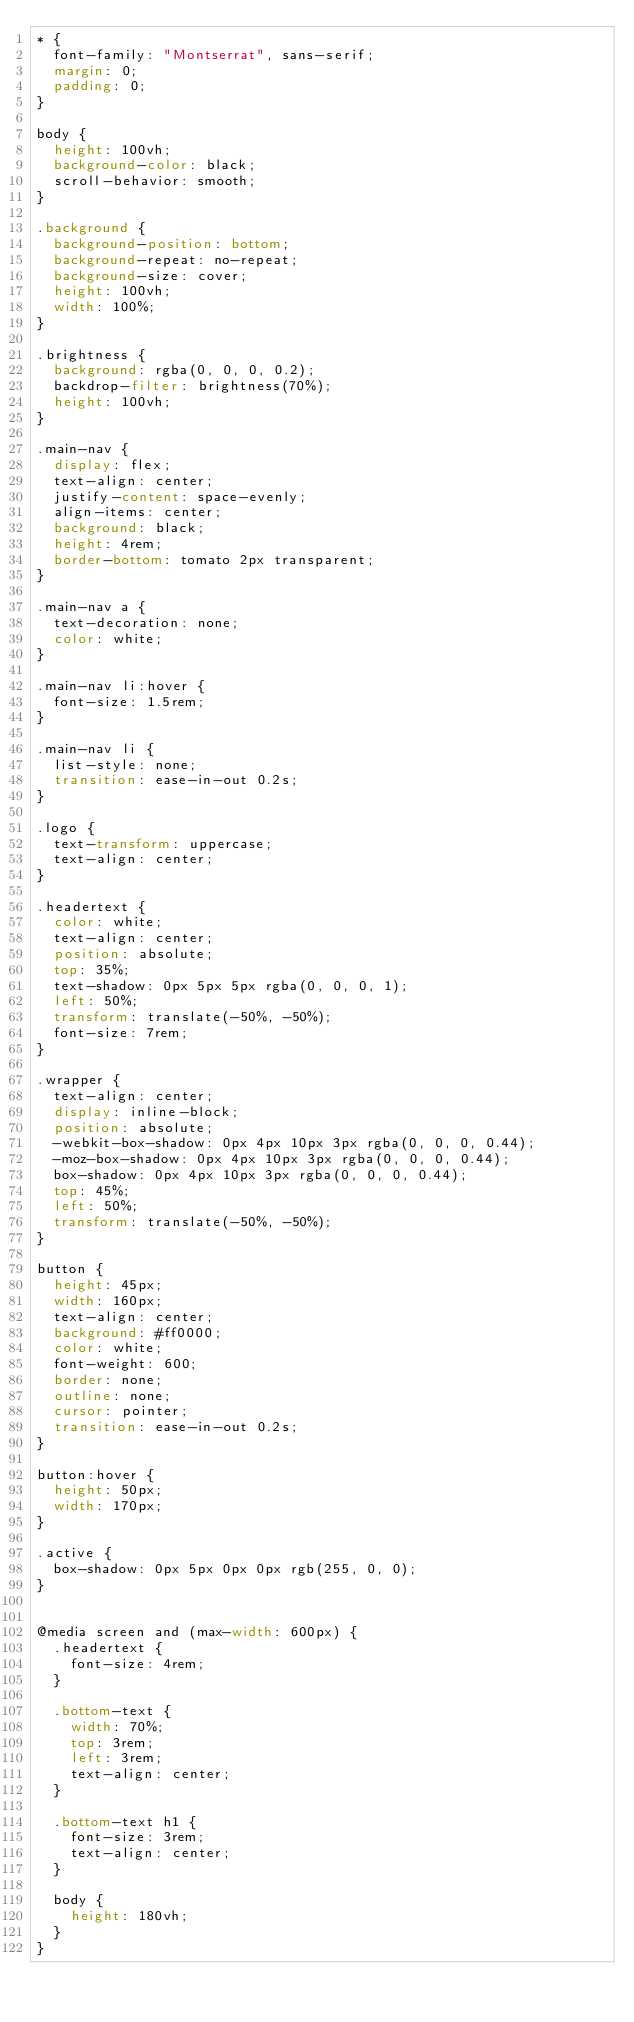<code> <loc_0><loc_0><loc_500><loc_500><_CSS_>* {
  font-family: "Montserrat", sans-serif;
  margin: 0;
  padding: 0;
}

body {
  height: 100vh;
  background-color: black;
  scroll-behavior: smooth;
}

.background {
  background-position: bottom;
  background-repeat: no-repeat;
  background-size: cover;
  height: 100vh;
  width: 100%;
}

.brightness {
  background: rgba(0, 0, 0, 0.2);
  backdrop-filter: brightness(70%);
  height: 100vh;
}

.main-nav {
  display: flex;
  text-align: center;
  justify-content: space-evenly;
  align-items: center;
  background: black;
  height: 4rem;
  border-bottom: tomato 2px transparent;
}

.main-nav a {
  text-decoration: none;
  color: white;
}

.main-nav li:hover {
  font-size: 1.5rem;
}

.main-nav li {
  list-style: none;
  transition: ease-in-out 0.2s;
}

.logo {
  text-transform: uppercase;
  text-align: center;
}

.headertext {
  color: white;
  text-align: center;
  position: absolute;
  top: 35%;
  text-shadow: 0px 5px 5px rgba(0, 0, 0, 1);
  left: 50%;
  transform: translate(-50%, -50%);
  font-size: 7rem;
}

.wrapper {
  text-align: center;
  display: inline-block;
  position: absolute;
  -webkit-box-shadow: 0px 4px 10px 3px rgba(0, 0, 0, 0.44);
  -moz-box-shadow: 0px 4px 10px 3px rgba(0, 0, 0, 0.44);
  box-shadow: 0px 4px 10px 3px rgba(0, 0, 0, 0.44);
  top: 45%;
  left: 50%;
  transform: translate(-50%, -50%);
}

button {
  height: 45px;
  width: 160px;
  text-align: center;
  background: #ff0000;
  color: white;
  font-weight: 600;
  border: none;
  outline: none;
  cursor: pointer;
  transition: ease-in-out 0.2s;
}

button:hover {
  height: 50px;
  width: 170px;
}

.active {
  box-shadow: 0px 5px 0px 0px rgb(255, 0, 0);
}


@media screen and (max-width: 600px) {
  .headertext {
    font-size: 4rem;
  }

  .bottom-text {
    width: 70%;
    top: 3rem;
    left: 3rem;
    text-align: center;
  }

  .bottom-text h1 {
    font-size: 3rem;
    text-align: center;
  }

  body {
    height: 180vh;
  }
}
</code> 